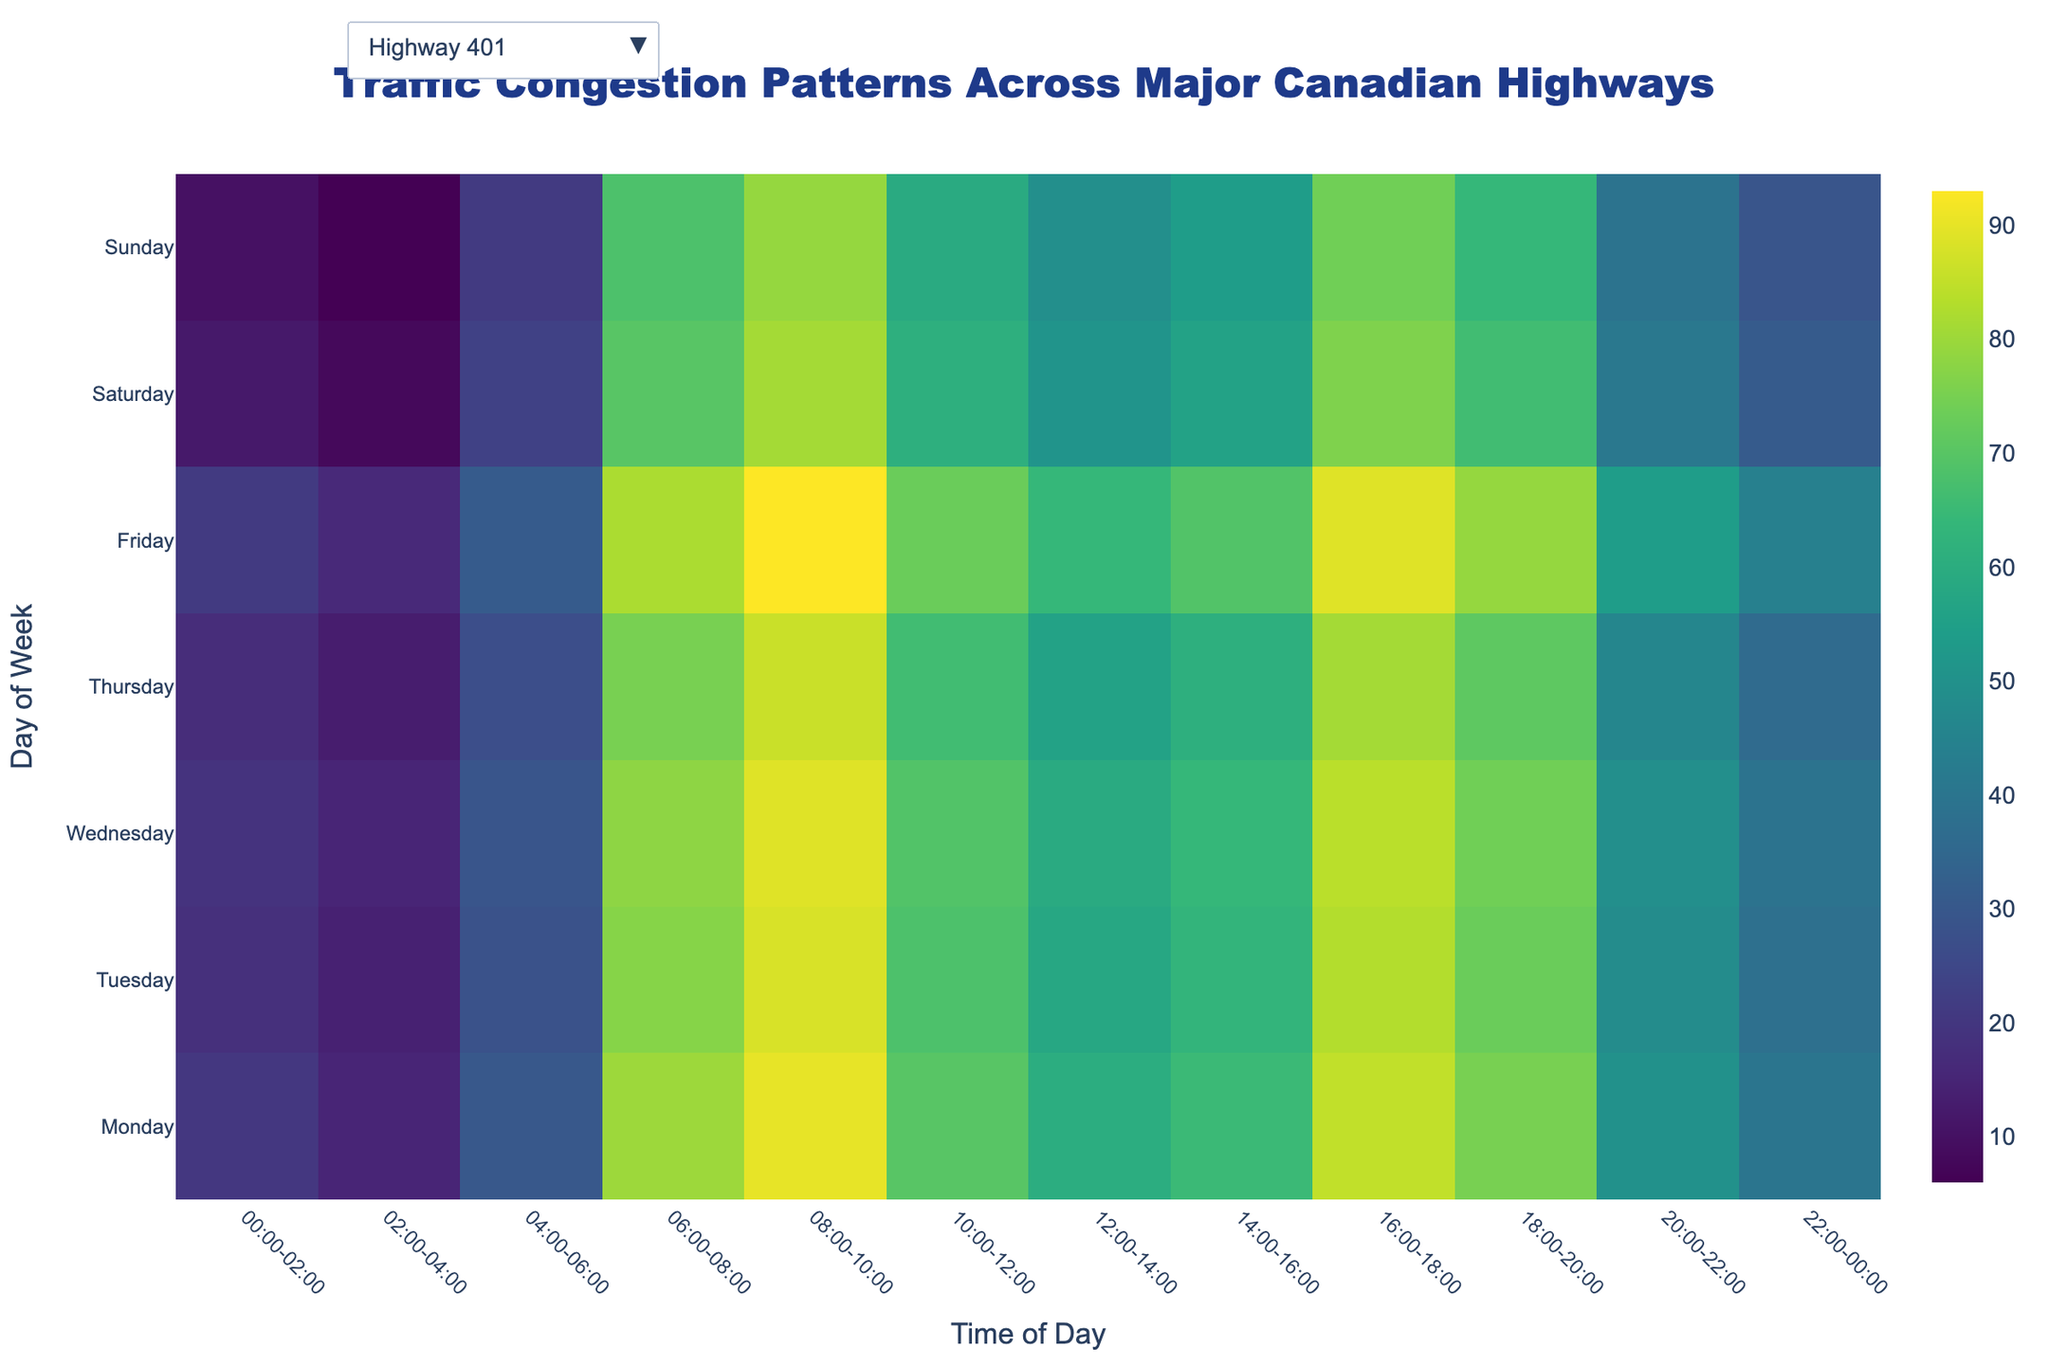Which day has the highest congestion on Highway 401 between 08:00 and 10:00? Locate the heatmap for Highway 401 and find the color intensity for each day within the time frame 08:00-10:00. The darkest color corresponds to the highest congestion, which is on Friday.
Answer: Friday What are the two periods with the lowest congestion on Highway 17 on Monday? Check the heatmap for Highway 17 on Monday and identify the two time periods with the lightest color, representing the lowest congestion. These periods are 02:00-04:00 and 00:00-02:00.
Answer: 02:00-04:00, 00:00-02:00 What is the average congestion level for TransCanada Highway on Wednesday from 06:00 to 18:00? For times 06:00-08:00, 08:00-10:00, 10:00-12:00, 12:00-14:00, 14:00-16:00, and 16:00-18:00, note the values: 68, 84, 64, 54, 59, and 79 respectively. Sum these values (68+84+64+54+59+79=408) and divide by the number of time periods (6).
Answer: 68 During which day and time is Highway 11 the least congested? Identify the heatmap for Highway 11 and find the lightest color to determine the lowest congestion. The day and time with the lowest value of 0 is Sunday from 02:00-04:00.
Answer: Sunday, 02:00-04:00 How does the congestion on Highway 401 at 06:00-08:00 compare between Monday and Wednesday? Examine the heatmap sections for 06:00-08:00 for both days. Monday shows 80, and Wednesday shows 78. Hence, Monday's congestion is slightly higher.
Answer: Monday is slightly higher What's the difference in congestion between Highway 11 and Highway 17 at 16:00-18:00 on Thursday? For 16:00-18:00 on Thursday, the values are 56 for Highway 11 and 36 for Highway 17. Subtract the value of Highway 17 from Highway 11 (56-36).
Answer: 20 Which time period generally has the highest congestion across all highways on Friday? Look for the darkest color regions within each highway's heatmap for Friday. The darkest colors appear in the 08:00-10:00 slot across most highways, indicating the highest congestion.
Answer: 08:00-10:00 